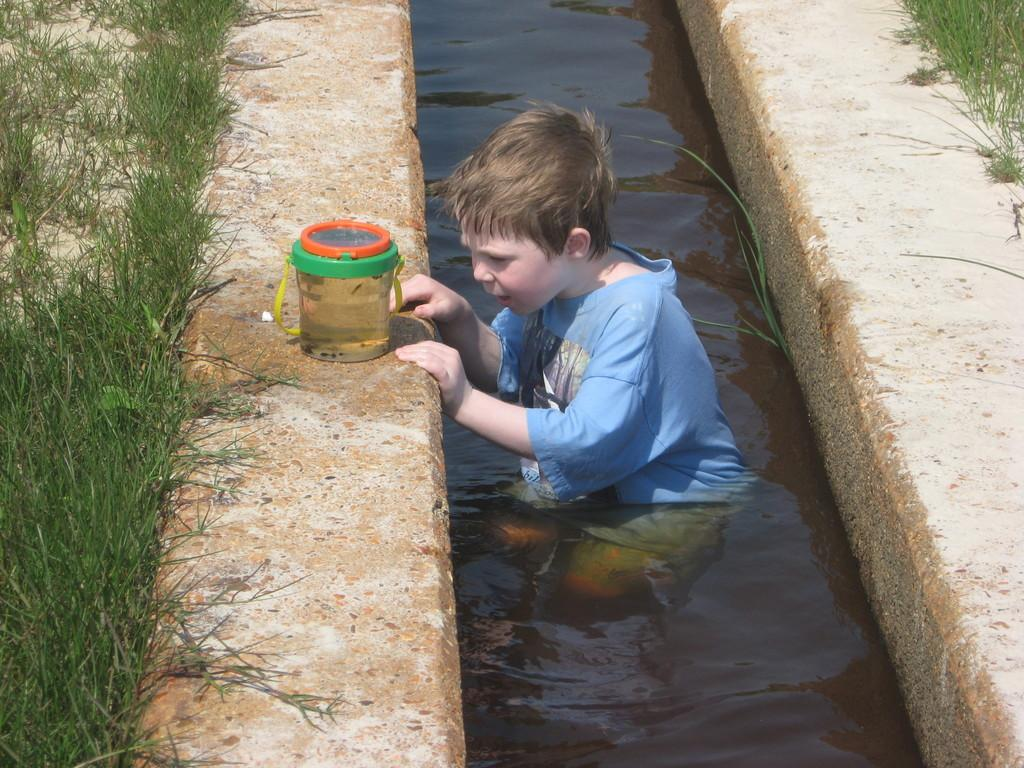What is the main subject of the image? The main subject of the image is a boy in the water in the center of the image. What else can be seen on the water's surface? There is a basket on the surface of the water. What type of vegetation is visible on both sides of the image? There is grass on both sides of the image. What type of jam is being spread on the plate in the image? There is no jam or plate present in the image. How many pipes can be seen in the image? There are no pipes visible in the image. 